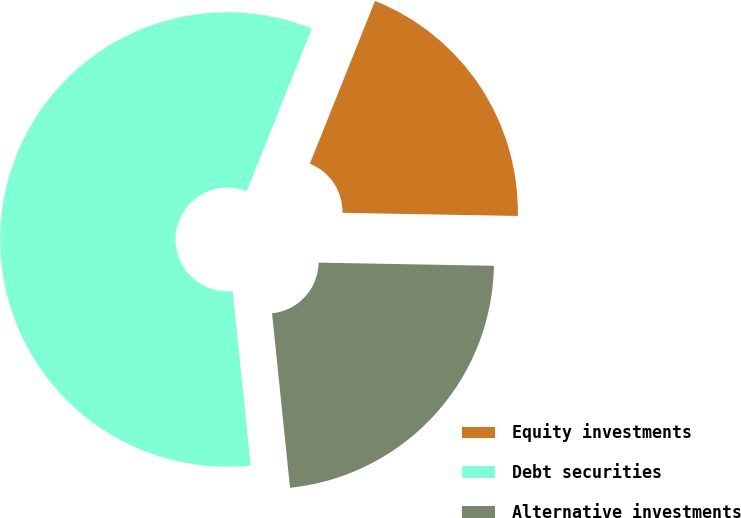Convert chart. <chart><loc_0><loc_0><loc_500><loc_500><pie_chart><fcel>Equity investments<fcel>Debt securities<fcel>Alternative investments<nl><fcel>19.23%<fcel>57.69%<fcel>23.08%<nl></chart> 